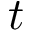<formula> <loc_0><loc_0><loc_500><loc_500>t</formula> 